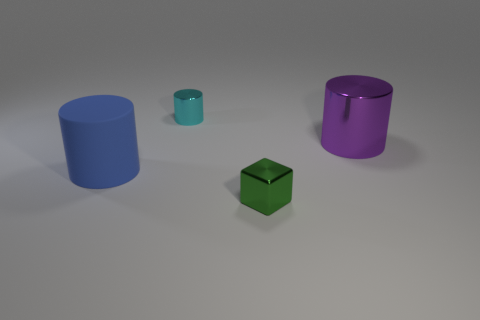What number of small metallic objects are both behind the big rubber thing and in front of the big blue rubber cylinder?
Provide a succinct answer. 0. There is a small thing left of the metal thing that is in front of the large blue rubber thing; is there a tiny cyan metal cylinder on the left side of it?
Offer a very short reply. No. What shape is the other thing that is the same size as the purple thing?
Your response must be concise. Cylinder. Is there a tiny metal object of the same color as the matte thing?
Offer a very short reply. No. Does the cyan object have the same shape as the big purple metallic thing?
Give a very brief answer. Yes. How many small objects are either blocks or cyan balls?
Provide a succinct answer. 1. There is a small block that is made of the same material as the small cyan object; what is its color?
Keep it short and to the point. Green. How many small green blocks are the same material as the large blue thing?
Your answer should be compact. 0. There is a metallic cylinder behind the big purple object; is it the same size as the shiny cylinder that is on the right side of the small cyan cylinder?
Your response must be concise. No. What material is the tiny thing that is behind the tiny shiny block in front of the purple object made of?
Offer a terse response. Metal. 